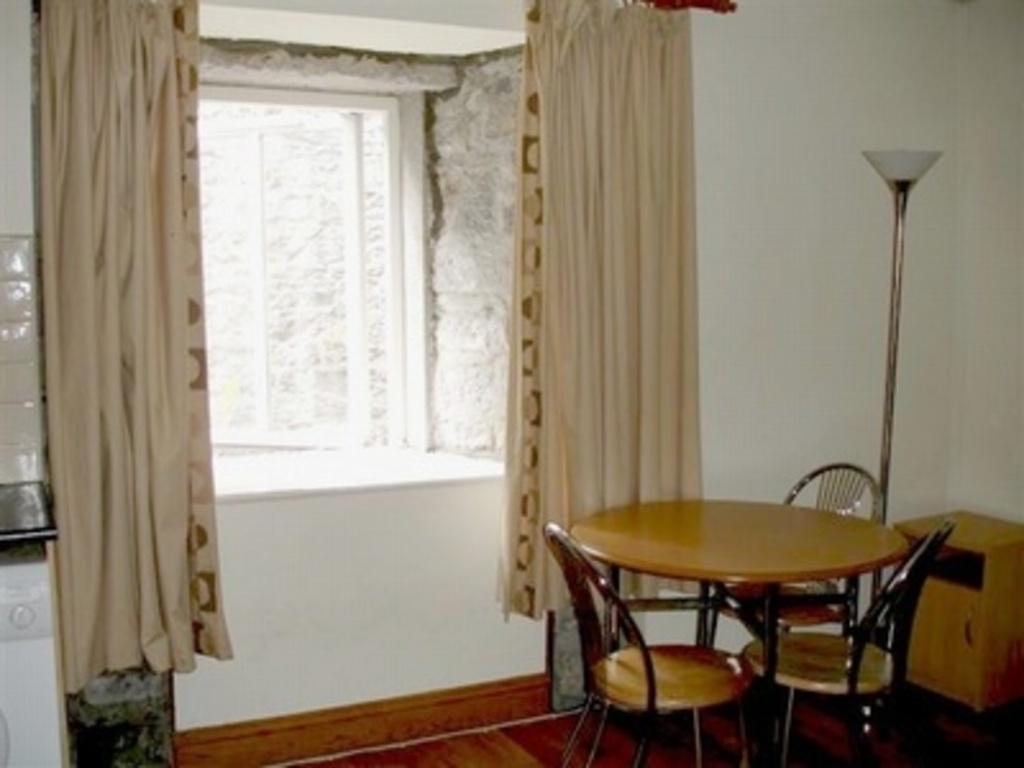How would you summarize this image in a sentence or two? In this image we can see a table and chairs near the table, there is a desk and light and a window with curtains. 